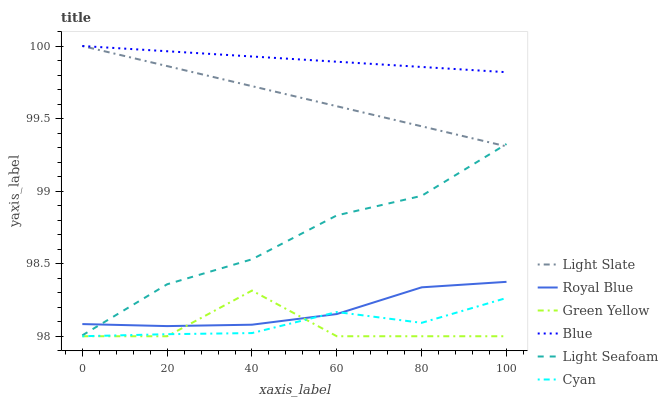Does Green Yellow have the minimum area under the curve?
Answer yes or no. Yes. Does Blue have the maximum area under the curve?
Answer yes or no. Yes. Does Light Seafoam have the minimum area under the curve?
Answer yes or no. No. Does Light Seafoam have the maximum area under the curve?
Answer yes or no. No. Is Light Slate the smoothest?
Answer yes or no. Yes. Is Green Yellow the roughest?
Answer yes or no. Yes. Is Light Seafoam the smoothest?
Answer yes or no. No. Is Light Seafoam the roughest?
Answer yes or no. No. Does Cyan have the lowest value?
Answer yes or no. Yes. Does Light Seafoam have the lowest value?
Answer yes or no. No. Does Light Slate have the highest value?
Answer yes or no. Yes. Does Light Seafoam have the highest value?
Answer yes or no. No. Is Green Yellow less than Light Seafoam?
Answer yes or no. Yes. Is Light Seafoam greater than Green Yellow?
Answer yes or no. Yes. Does Royal Blue intersect Cyan?
Answer yes or no. Yes. Is Royal Blue less than Cyan?
Answer yes or no. No. Is Royal Blue greater than Cyan?
Answer yes or no. No. Does Green Yellow intersect Light Seafoam?
Answer yes or no. No. 